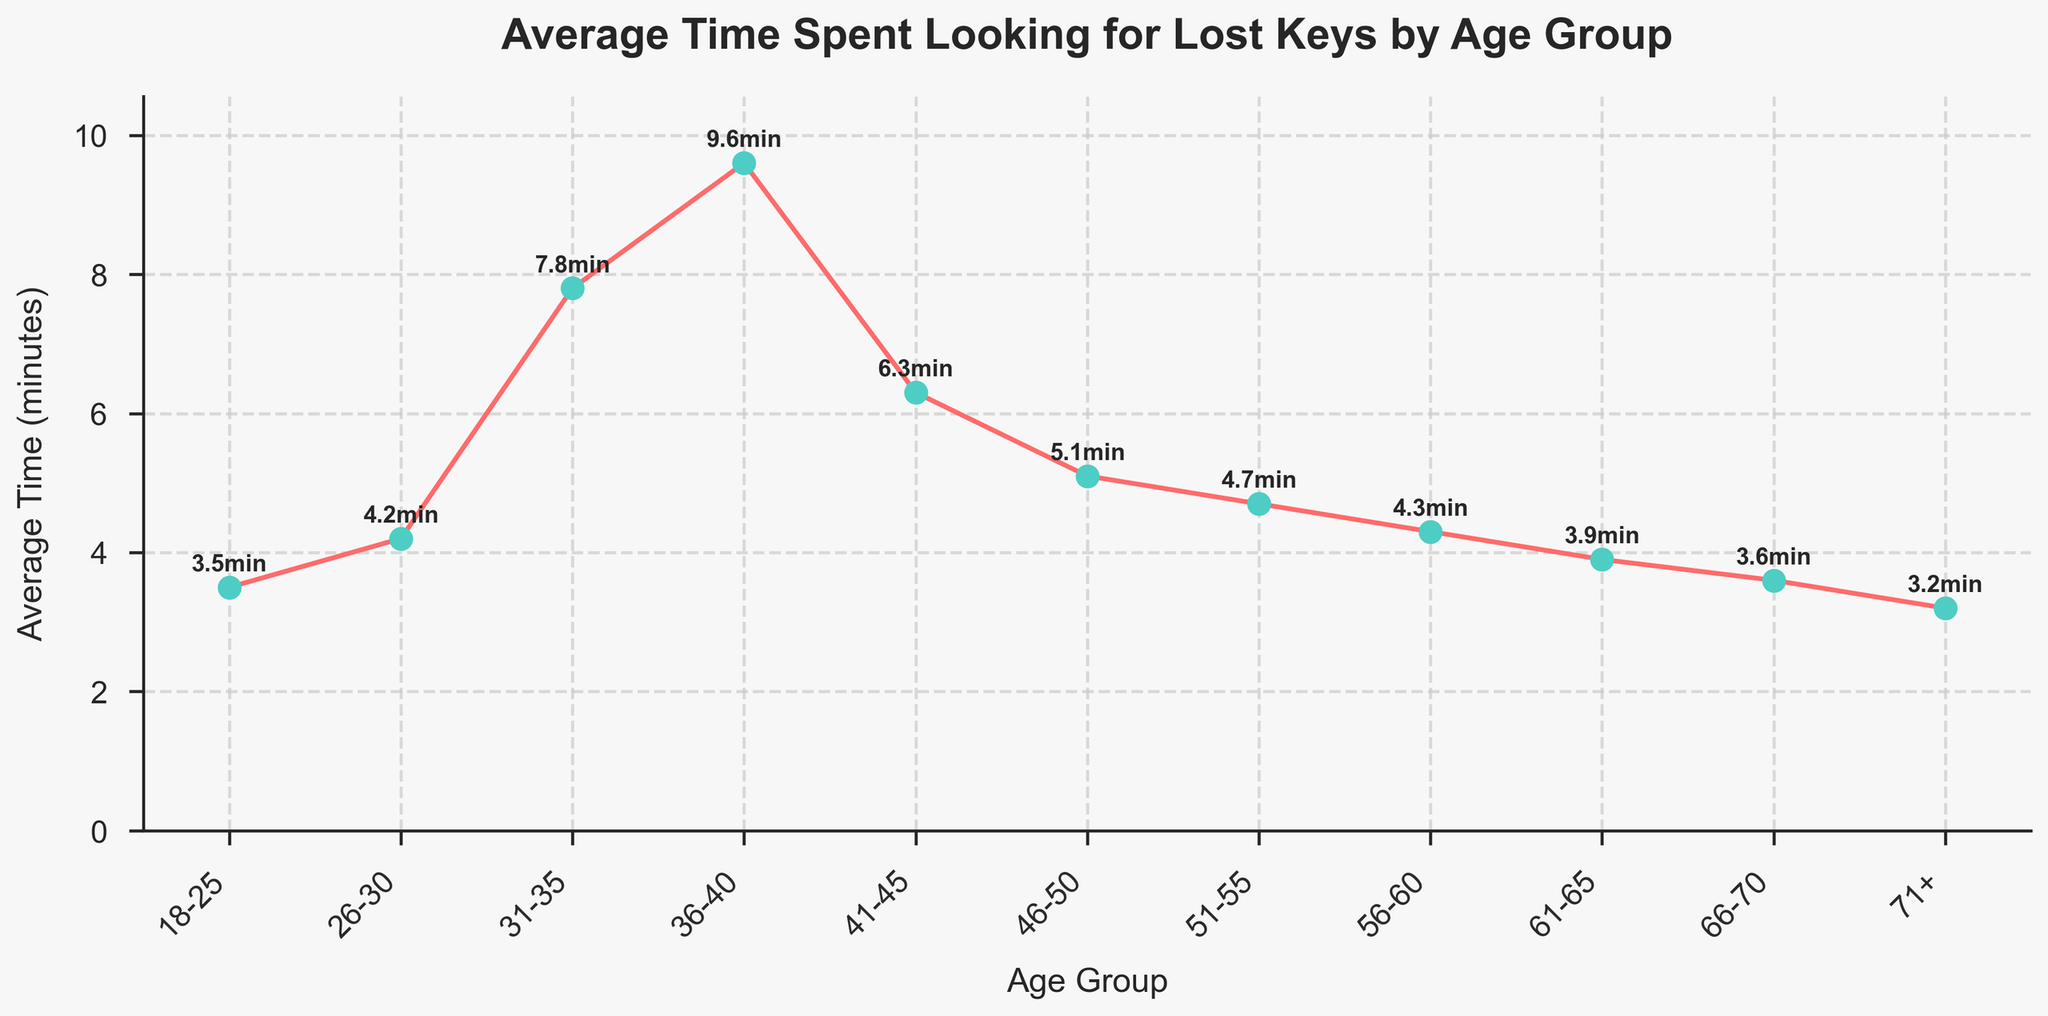What age group spends the most time looking for lost keys? The figure shows that the 36-40 age group has the highest point on the line chart, indicating this group spends the most time looking for lost keys.
Answer: 36-40 What's the average time spent looking for lost keys across all age groups? Add up the average times spent for each age group, which are 3.5, 4.2, 7.8, 9.6, 6.3, 5.1, 4.7, 4.3, 3.9, 3.6, and 3.2. The sum is 56.2. Since there are 11 age groups, divide 56.2 by 11 to get the average. 56.2 / 11 = 5.11
Answer: 5.11 Which two age groups have the closest average time spent looking for lost keys? Compare the differences between the average times spent for each pair of consecutive age groups. The closest difference is between age groups 66-70 and 71+ where the average times are 3.6 and 3.2 respectively, and the difference is 0.4.
Answer: 66-70 and 71+ Is the time spent looking for lost keys higher in the 41-45 age group than in the 31-35 age group? Compare the average time values for the 41-45 age group (6.3) and the 31-35 age group (7.8). Since 6.3 is less than 7.8, the 41-45 age group spends less time.
Answer: No What is the difference in the average time spent looking for lost keys between the youngest and oldest age groups? The youngest age group (18-25) spends an average of 3.5 minutes, and the oldest age group (71+) spends 3.2 minutes. Subtract 3.2 from 3.5 to get the difference. 3.5 - 3.2 = 0.3
Answer: 0.3 What is the median average time spent looking for lost keys across the age groups? List the average times in ascending order: 3.2, 3.5, 3.6, 3.9, 4.2, 4.3, 4.7, 5.1, 6.3, 7.8, 9.6. The median is the middle value in this ordered list, which is 4.3 minutes.
Answer: 4.3 Which age group shows a significant spike in the average time spent looking for lost keys, based on the visual representation? The figure clearly shows a steep increase in the time spent looking for lost keys for the 31-40 age groups, with a notable spike at the 36-40 age group.
Answer: 36-40 